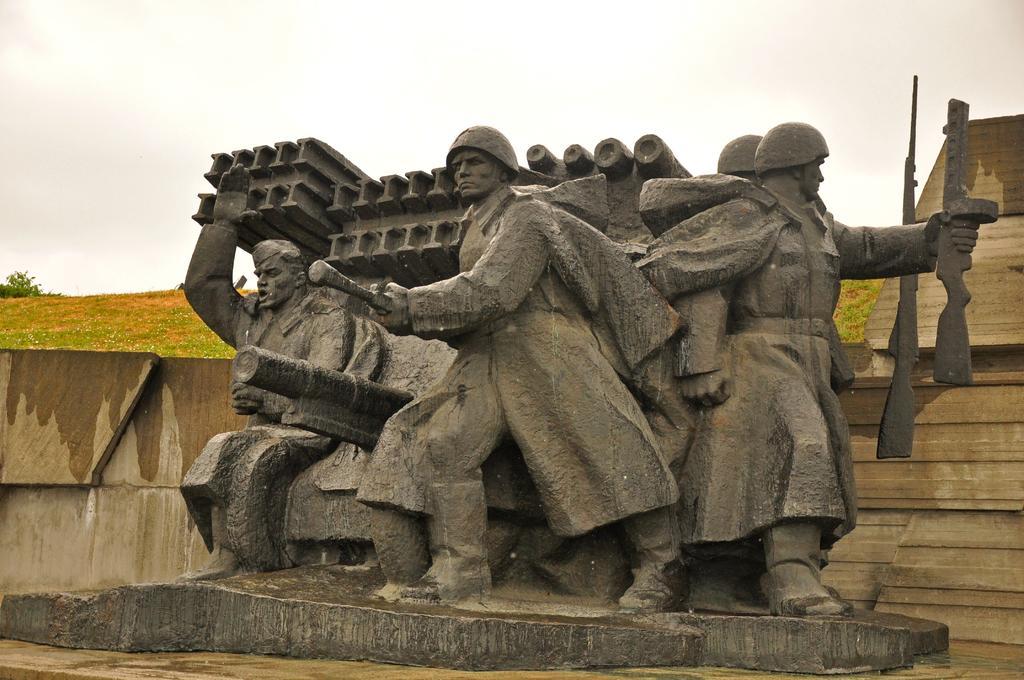Could you give a brief overview of what you see in this image? In this image we can see the sculpture which represent some people holding objects in their hands and there is a wall in the background and at the top we can see the sky. 